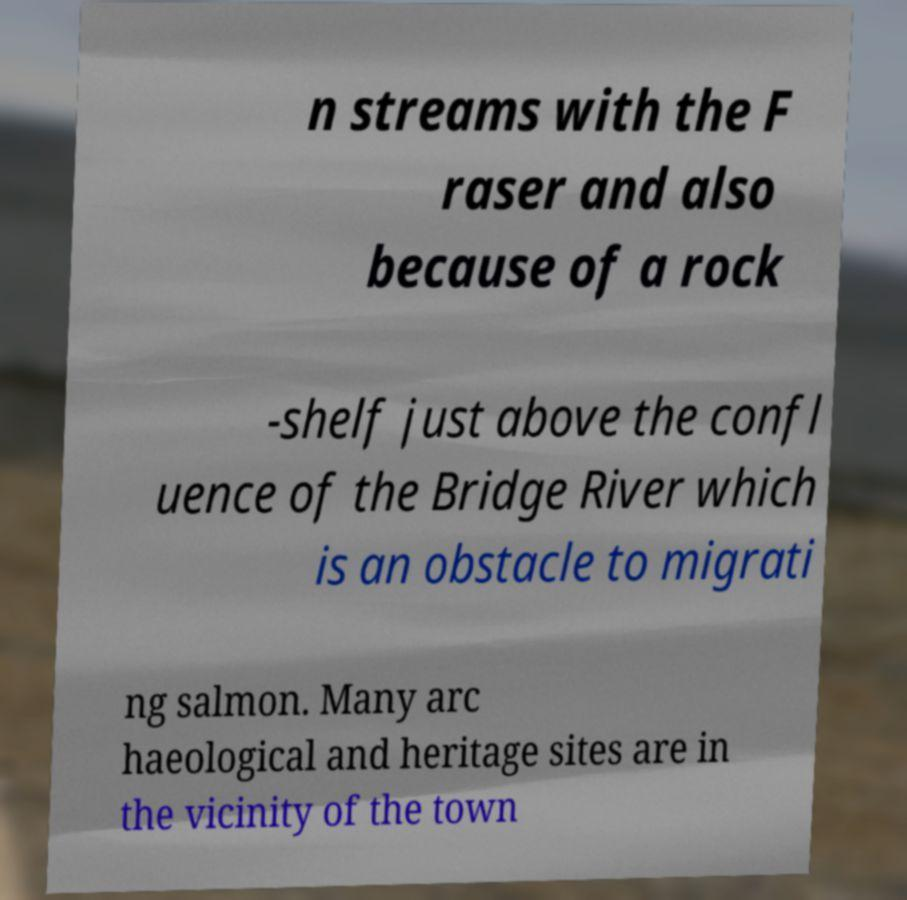What messages or text are displayed in this image? I need them in a readable, typed format. n streams with the F raser and also because of a rock -shelf just above the confl uence of the Bridge River which is an obstacle to migrati ng salmon. Many arc haeological and heritage sites are in the vicinity of the town 